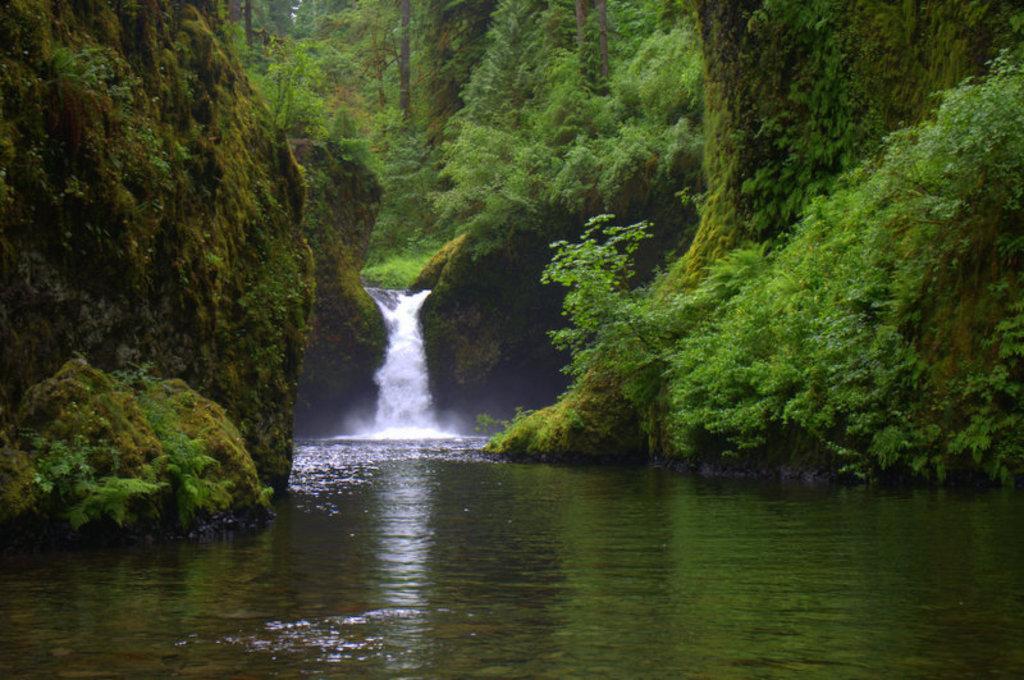Can you describe this image briefly? In this image, we can see some trees and hills. There is a waterfall in the middle of the image. 